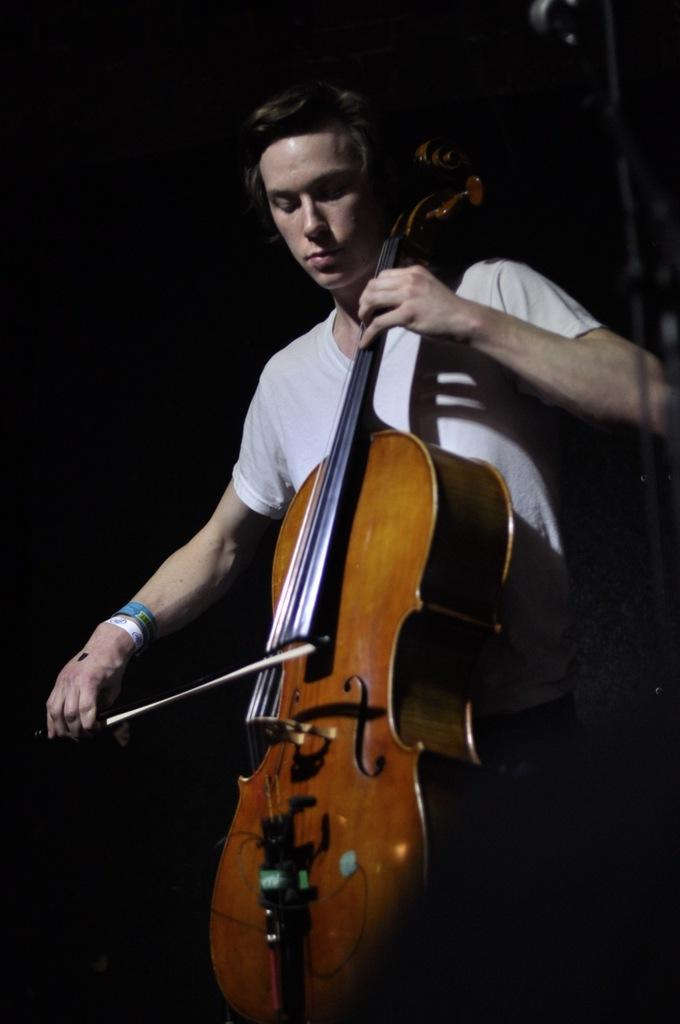What is the main subject of the image? There is a person in the image. What is the person wearing? The person is wearing a white T-shirt. What is the person doing in the image? The person is playing a musical instrument. What can be observed about the background of the image? The background of the image is dark. Can you see any bats flying around the person in the image? There are no bats visible in the image. What type of quill is the person using to play the musical instrument? The person is not using a quill to play the musical instrument; they are likely using their hands or a pick. 